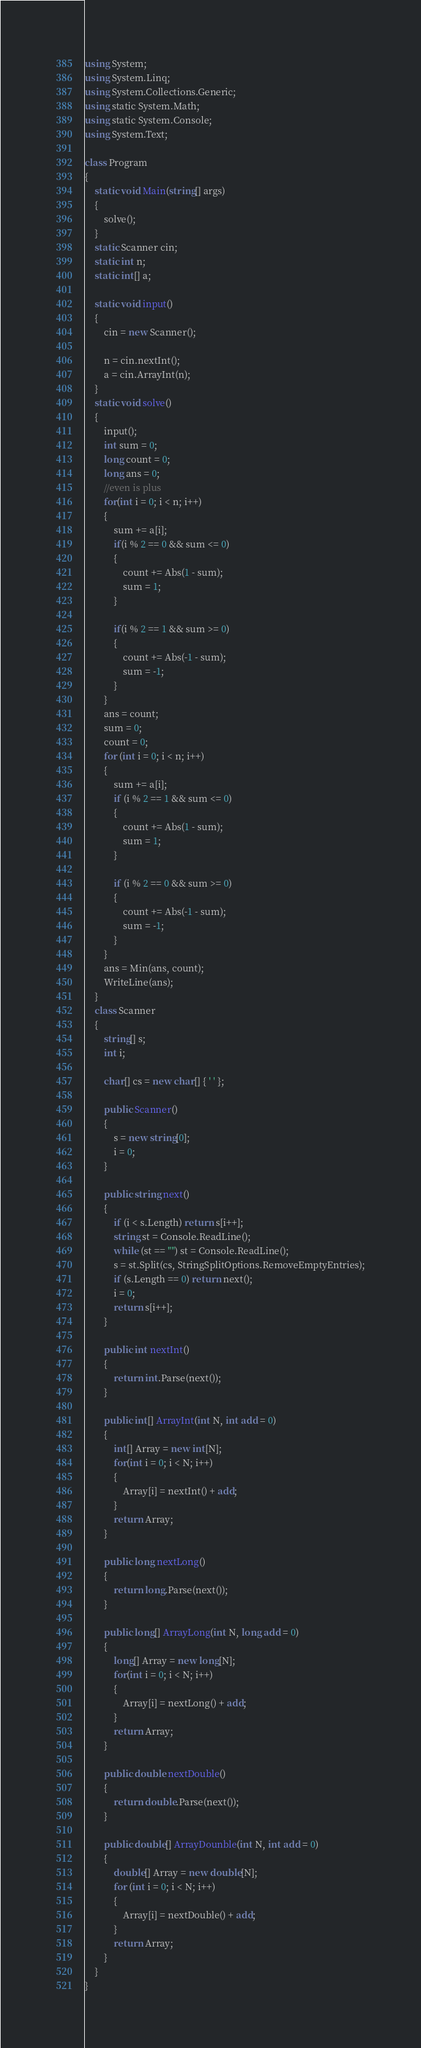Convert code to text. <code><loc_0><loc_0><loc_500><loc_500><_C#_>using System;
using System.Linq;
using System.Collections.Generic;
using static System.Math;
using static System.Console;
using System.Text;

class Program
{
    static void Main(string[] args)
    {
        solve();
    }
    static Scanner cin;
    static int n;
    static int[] a;

    static void input()
    {
        cin = new Scanner();

        n = cin.nextInt();
        a = cin.ArrayInt(n);
    }
    static void solve()
    {
        input();
        int sum = 0;
        long count = 0;
        long ans = 0;
        //even is plus
        for(int i = 0; i < n; i++)
        {
            sum += a[i];
            if(i % 2 == 0 && sum <= 0)
            {
                count += Abs(1 - sum);
                sum = 1;
            }

            if(i % 2 == 1 && sum >= 0)
            {
                count += Abs(-1 - sum);
                sum = -1;
            }
        }
        ans = count;
        sum = 0;
        count = 0;
        for (int i = 0; i < n; i++)
        {
            sum += a[i];
            if (i % 2 == 1 && sum <= 0)
            {
                count += Abs(1 - sum);
                sum = 1;
            }

            if (i % 2 == 0 && sum >= 0)
            {
                count += Abs(-1 - sum);
                sum = -1;
            }
        }
        ans = Min(ans, count);
        WriteLine(ans);
    }
    class Scanner
    {
        string[] s;
        int i;

        char[] cs = new char[] { ' ' };

        public Scanner()
        {
            s = new string[0];
            i = 0;
        }
        
        public string next()
        {
            if (i < s.Length) return s[i++];
            string st = Console.ReadLine();
            while (st == "") st = Console.ReadLine();
            s = st.Split(cs, StringSplitOptions.RemoveEmptyEntries);
            if (s.Length == 0) return next();
            i = 0;
            return s[i++];
        }

        public int nextInt()
        {
            return int.Parse(next());
        }

        public int[] ArrayInt(int N, int add = 0)
        {
            int[] Array = new int[N];
            for(int i = 0; i < N; i++)
            {
                Array[i] = nextInt() + add;
            }
            return Array;
        }

        public long nextLong()
        {
            return long.Parse(next());
        }

        public long[] ArrayLong(int N, long add = 0)
        {
            long[] Array = new long[N];
            for(int i = 0; i < N; i++)
            {
                Array[i] = nextLong() + add;
            }
            return Array;
        }

        public double nextDouble()
        {
            return double.Parse(next());
        }

        public double[] ArrayDounble(int N, int add = 0)
        {
            double[] Array = new double[N];
            for (int i = 0; i < N; i++)
            {
                Array[i] = nextDouble() + add;
            }
            return Array;
        }
    }
}</code> 